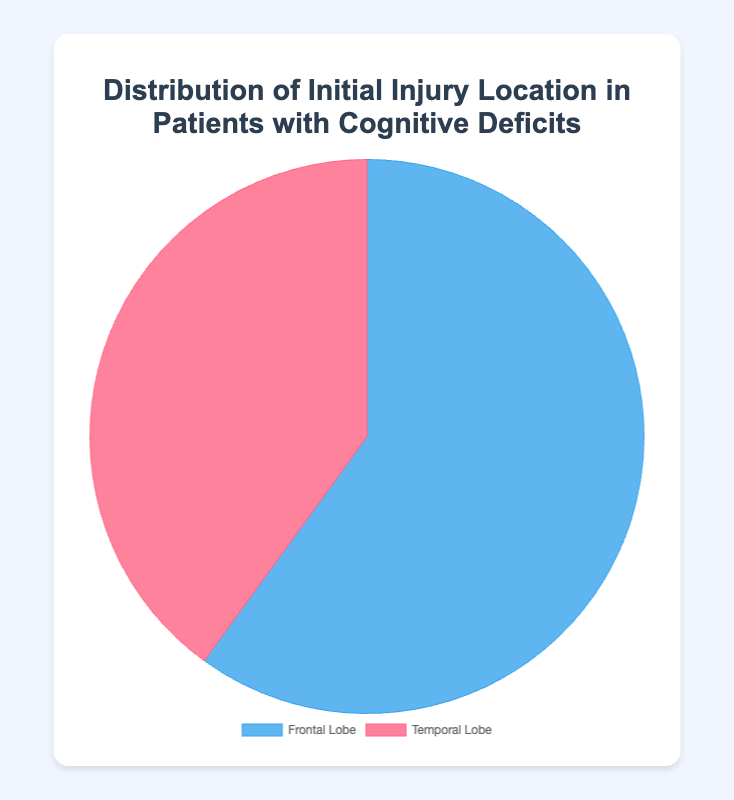What's the percentage of patients with injuries in the Frontal Lobe? From the pie chart, the section labeled "Frontal Lobe" represents 60%. This means that 60% of patients have initial injuries in the Frontal Lobe.
Answer: 60% What is the difference in percentage between patients with Frontal Lobe injuries and Temporal Lobe injuries? The pie chart shows 60% for Frontal Lobe and 40% for Temporal Lobe. Subtracting 40% from 60% gives the difference.
Answer: 20% Which injury location has a higher percentage of patients, Frontal Lobe or Temporal Lobe? Comparing the percentages in the pie chart, 60% of patients have injuries in the Frontal Lobe while 40% in the Temporal Lobe. Frontal Lobe has a higher percentage.
Answer: Frontal Lobe What fraction of patients have Temporal Lobe injuries in simple terms? The pie chart shows 40% of patients have Temporal Lobe injuries. In fraction form, this is 40/100 which simplifies to 2/5.
Answer: 2/5 What fraction of patients have Frontal Lobe injuries in simple terms? The chart indicates 60% of patients have Frontal Lobe injuries. In fraction terms, this is 60/100 which simplifies to 3/5.
Answer: 3/5 What is the ratio of patients with Frontal Lobe injuries to those with Temporal Lobe injuries? The chart shows 60% for Frontal Lobe and 40% for Temporal Lobe. The ratio is 60:40, which simplifies to 3:2.
Answer: 3:2 Are more than half of the patients suffering from Frontal Lobe injuries? The pie chart shows 60% of the patients have Frontal Lobe injuries. Since 60% is more than half, the answer is yes.
Answer: Yes 